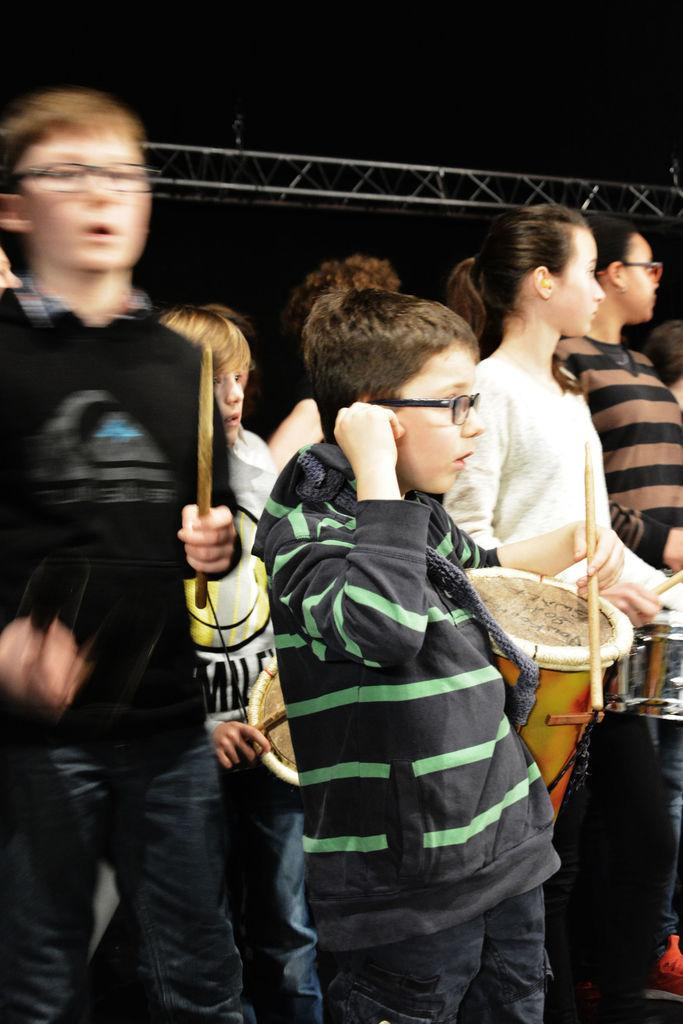What is the main subject of the image? The main subject of the image is a group of children. What are some of the children doing in the image? Some children are standing, while others are playing drums. Can you describe the children's positions in the image? Some children are standing, while others are seated or crouched while playing drums. What type of glass is being used to create the children's laughter in the image? There is no glass present in the image, and the children's laughter is not created by any object. 